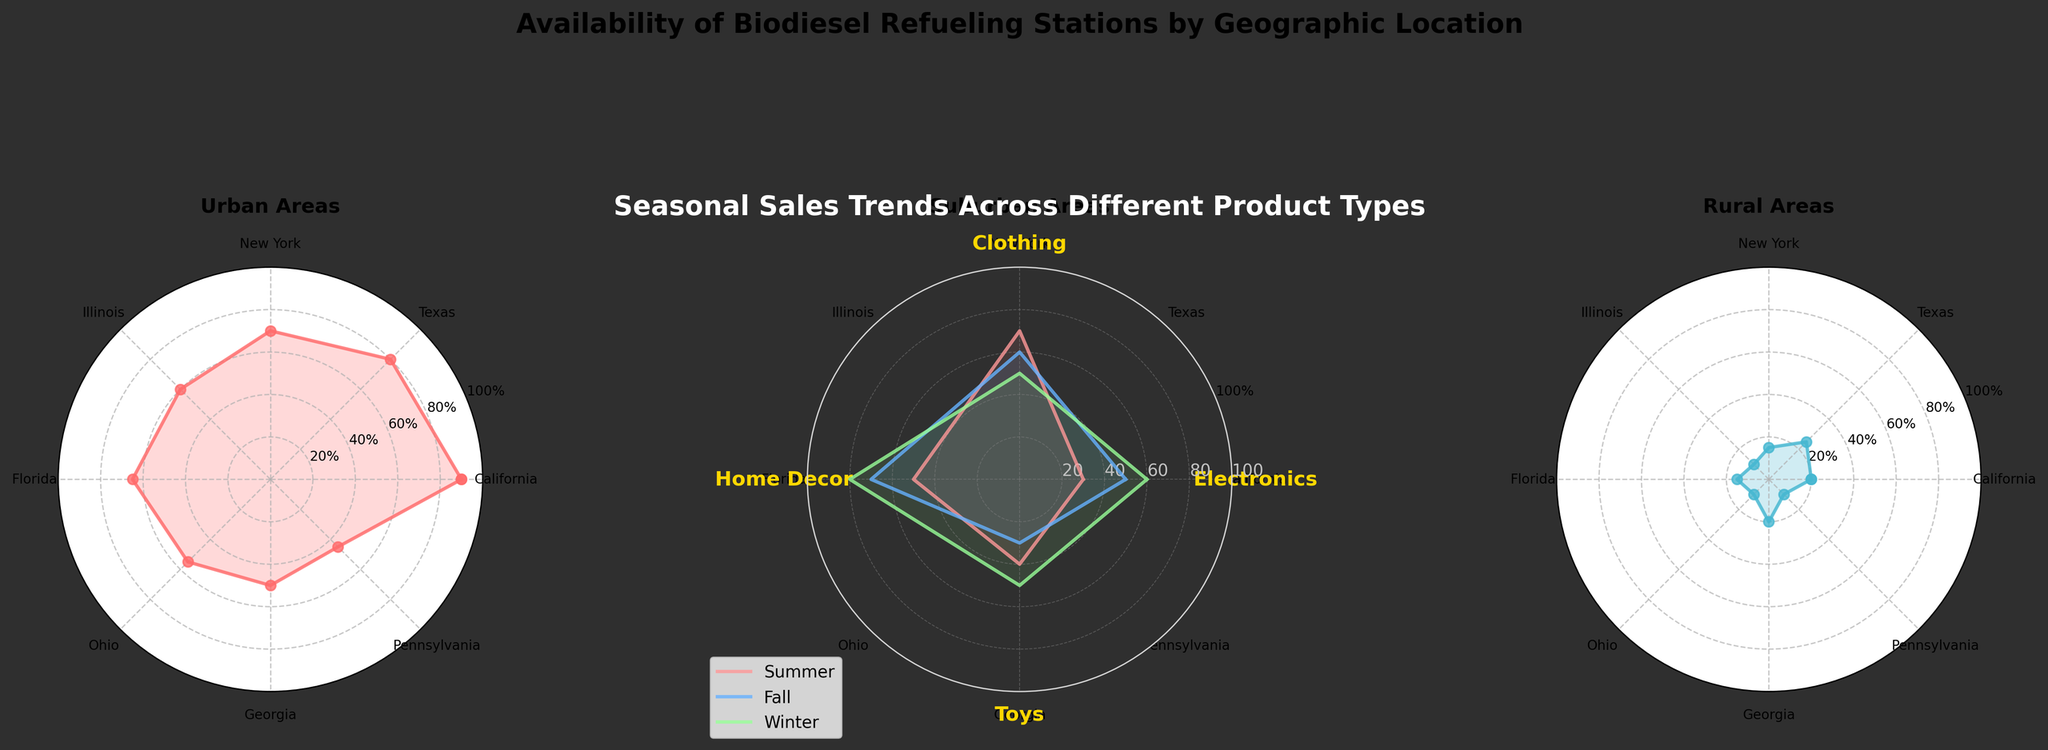What is the title of the radar chart? The title of the radar chart is usually displayed at the top of the chart. It is a textual element meant to give a summary of what the chart is about.
Answer: Seasonal Sales Trends Across Different Product Types How many product types are displayed on the radar chart? By examining the categories on the perimeter of the radar chart, you can count the distinct product types.
Answer: 4 Which season shows the highest sales for Electronics? Look at the lines corresponding to each season and identify which one reaches the highest point on the Electronics axis.
Answer: Winter What are the sales values for Home Decor across all seasons? Follow the points along the Home Decor axis for all three seasons and note down their values.
Answer: 50, 70, 80 Which product type has the lowest sales in Fall? Trace along the axes for the Fall data and find the product type that has the smallest value.
Answer: Toys In which season do Home Decor sales peak? Look at the values along the Home Decor axis and determine in which season the highest point occurs.
Answer: Winter What is the average sales value for Toys across all seasons? Add up the sales values for Toys in all the seasons and divide by the number of seasons. So (40 + 30 + 50) / 3 = 40.
Answer: 40 Are the sales of Clothing higher in Summer or Fall? Compare the heights of the points for Clothing in Summer and Fall directly from the radar chart.
Answer: Summer Which season has the most evenly distributed sales across all product types? Look at the distribution of points for each season and identify the one with the least variation in sales values across all product types.
Answer: Winter Do sales for any product type remain constant across all seasons? Observe the lines for each product type and check if any line remains at the same value across all seasons.
Answer: No 